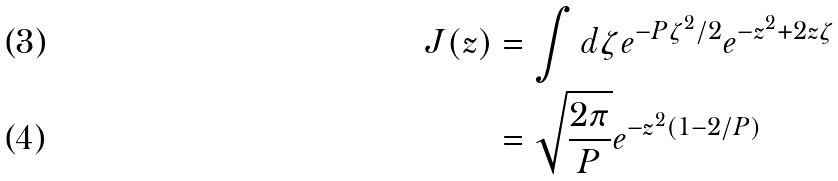<formula> <loc_0><loc_0><loc_500><loc_500>J ( z ) & = \int d \zeta e ^ { - P \zeta ^ { 2 } / 2 } e ^ { - z ^ { 2 } + 2 z \zeta } \\ & = \sqrt { \frac { 2 \pi } { P } } e ^ { - z ^ { 2 } ( 1 - 2 / P ) }</formula> 